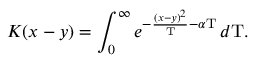Convert formula to latex. <formula><loc_0><loc_0><loc_500><loc_500>K ( x - y ) = \int _ { 0 } ^ { \infty } e ^ { - { \frac { ( x - y ) ^ { 2 } } { T } } - \alpha T } \, d T .</formula> 